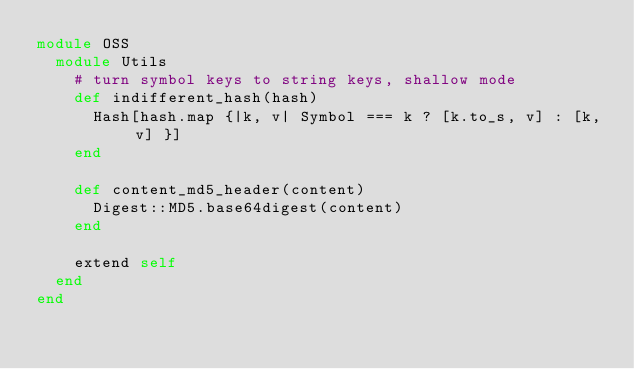<code> <loc_0><loc_0><loc_500><loc_500><_Ruby_>module OSS
  module Utils
    # turn symbol keys to string keys, shallow mode
    def indifferent_hash(hash)
      Hash[hash.map {|k, v| Symbol === k ? [k.to_s, v] : [k, v] }]
    end

    def content_md5_header(content)
      Digest::MD5.base64digest(content)
    end

    extend self
  end
end
</code> 